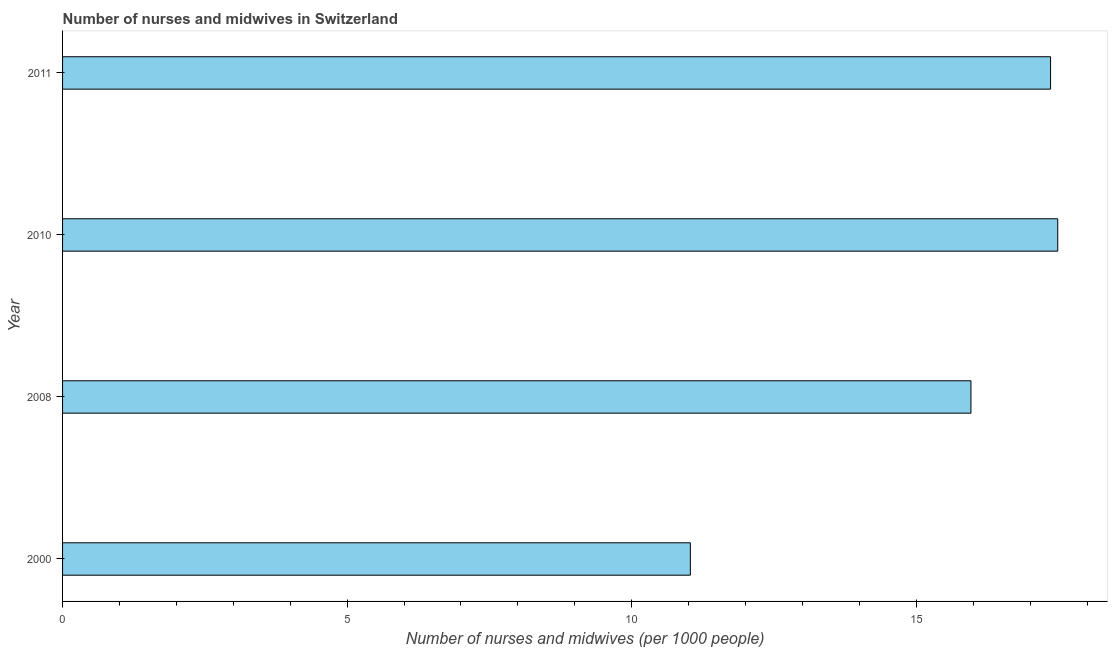What is the title of the graph?
Offer a very short reply. Number of nurses and midwives in Switzerland. What is the label or title of the X-axis?
Your answer should be very brief. Number of nurses and midwives (per 1000 people). What is the label or title of the Y-axis?
Make the answer very short. Year. What is the number of nurses and midwives in 2008?
Provide a short and direct response. 15.96. Across all years, what is the maximum number of nurses and midwives?
Your answer should be compact. 17.48. Across all years, what is the minimum number of nurses and midwives?
Your response must be concise. 11.03. In which year was the number of nurses and midwives minimum?
Give a very brief answer. 2000. What is the sum of the number of nurses and midwives?
Your answer should be compact. 61.83. What is the difference between the number of nurses and midwives in 2008 and 2010?
Offer a terse response. -1.52. What is the average number of nurses and midwives per year?
Provide a short and direct response. 15.46. What is the median number of nurses and midwives?
Your answer should be compact. 16.66. In how many years, is the number of nurses and midwives greater than 17 ?
Ensure brevity in your answer.  2. What is the difference between the highest and the second highest number of nurses and midwives?
Provide a short and direct response. 0.13. What is the difference between the highest and the lowest number of nurses and midwives?
Your response must be concise. 6.46. In how many years, is the number of nurses and midwives greater than the average number of nurses and midwives taken over all years?
Ensure brevity in your answer.  3. What is the Number of nurses and midwives (per 1000 people) of 2000?
Your answer should be compact. 11.03. What is the Number of nurses and midwives (per 1000 people) in 2008?
Offer a terse response. 15.96. What is the Number of nurses and midwives (per 1000 people) in 2010?
Ensure brevity in your answer.  17.48. What is the Number of nurses and midwives (per 1000 people) in 2011?
Provide a succinct answer. 17.36. What is the difference between the Number of nurses and midwives (per 1000 people) in 2000 and 2008?
Offer a terse response. -4.93. What is the difference between the Number of nurses and midwives (per 1000 people) in 2000 and 2010?
Give a very brief answer. -6.46. What is the difference between the Number of nurses and midwives (per 1000 people) in 2000 and 2011?
Provide a succinct answer. -6.33. What is the difference between the Number of nurses and midwives (per 1000 people) in 2008 and 2010?
Your answer should be very brief. -1.52. What is the difference between the Number of nurses and midwives (per 1000 people) in 2008 and 2011?
Your response must be concise. -1.4. What is the difference between the Number of nurses and midwives (per 1000 people) in 2010 and 2011?
Ensure brevity in your answer.  0.13. What is the ratio of the Number of nurses and midwives (per 1000 people) in 2000 to that in 2008?
Offer a very short reply. 0.69. What is the ratio of the Number of nurses and midwives (per 1000 people) in 2000 to that in 2010?
Offer a very short reply. 0.63. What is the ratio of the Number of nurses and midwives (per 1000 people) in 2000 to that in 2011?
Offer a terse response. 0.64. What is the ratio of the Number of nurses and midwives (per 1000 people) in 2008 to that in 2010?
Offer a very short reply. 0.91. What is the ratio of the Number of nurses and midwives (per 1000 people) in 2008 to that in 2011?
Your response must be concise. 0.92. What is the ratio of the Number of nurses and midwives (per 1000 people) in 2010 to that in 2011?
Your answer should be compact. 1.01. 